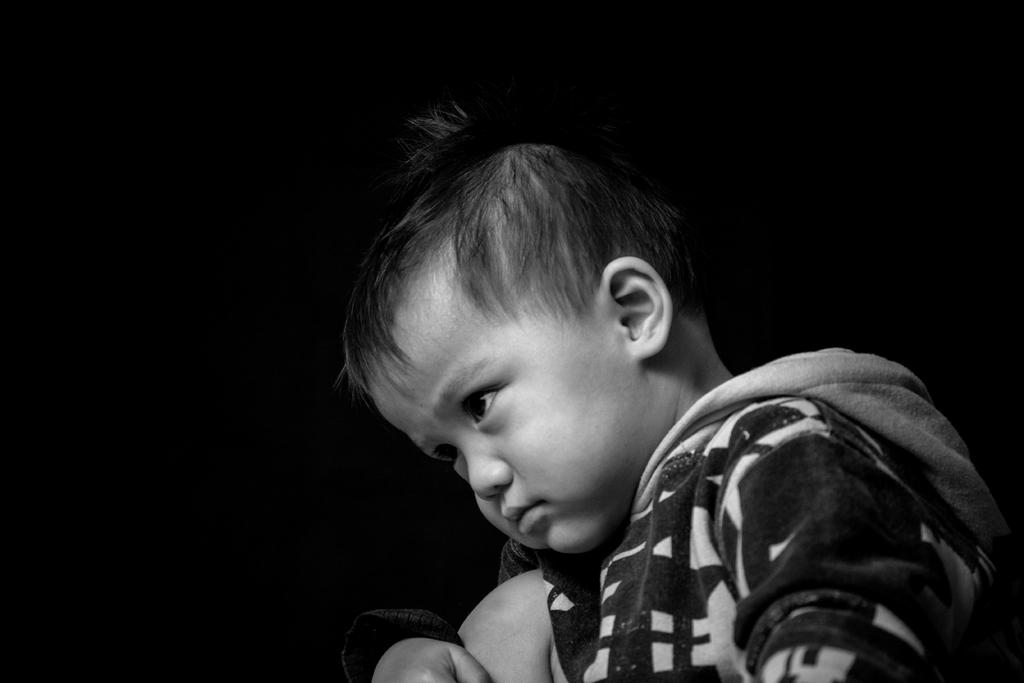What is the color scheme of the image? The image is black and white. Who or what is the main subject in the image? There is a boy in the image. What can be observed about the background of the image? The background of the image is dark. What type of bat is hanging from the tree in the image? There is no bat or tree present in the image; it features a boy in a dark background. What color is the dress worn by the boy in the image? The image is black and white, and there is no dress visible in the image. 